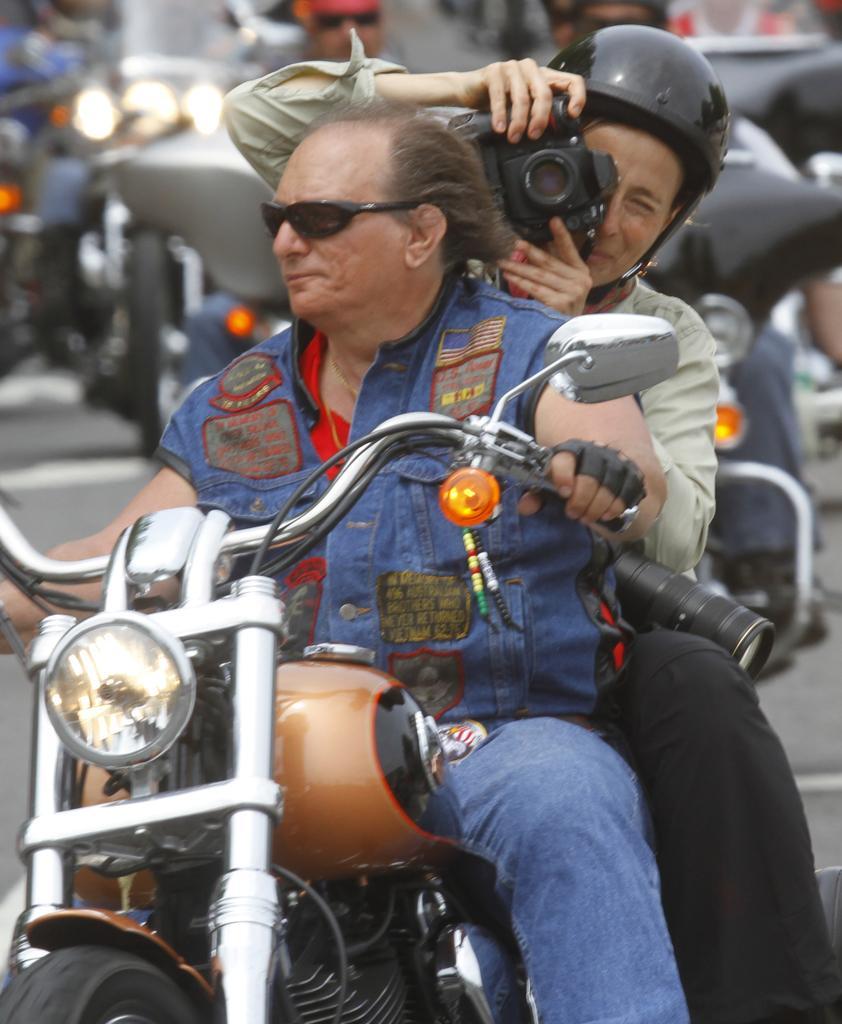Please provide a concise description of this image. In this picture we can see man wore goggles, jacket riding bike and at back of his woman wore helmet holding camera in her hand and sitting and in background we can see other person also riding bike on road. 